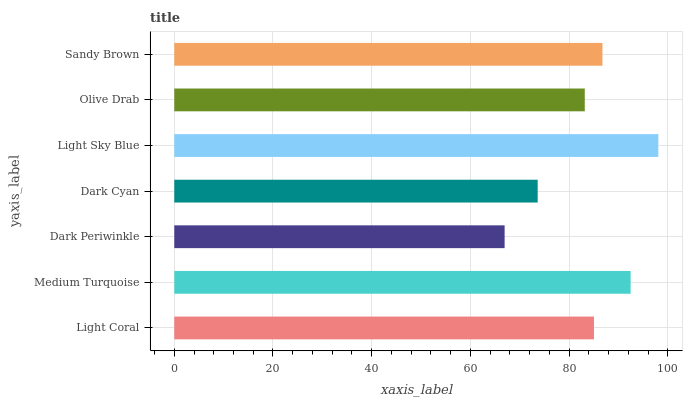Is Dark Periwinkle the minimum?
Answer yes or no. Yes. Is Light Sky Blue the maximum?
Answer yes or no. Yes. Is Medium Turquoise the minimum?
Answer yes or no. No. Is Medium Turquoise the maximum?
Answer yes or no. No. Is Medium Turquoise greater than Light Coral?
Answer yes or no. Yes. Is Light Coral less than Medium Turquoise?
Answer yes or no. Yes. Is Light Coral greater than Medium Turquoise?
Answer yes or no. No. Is Medium Turquoise less than Light Coral?
Answer yes or no. No. Is Light Coral the high median?
Answer yes or no. Yes. Is Light Coral the low median?
Answer yes or no. Yes. Is Light Sky Blue the high median?
Answer yes or no. No. Is Olive Drab the low median?
Answer yes or no. No. 